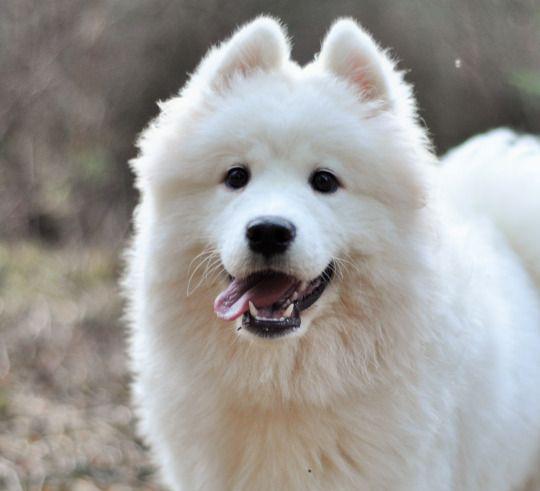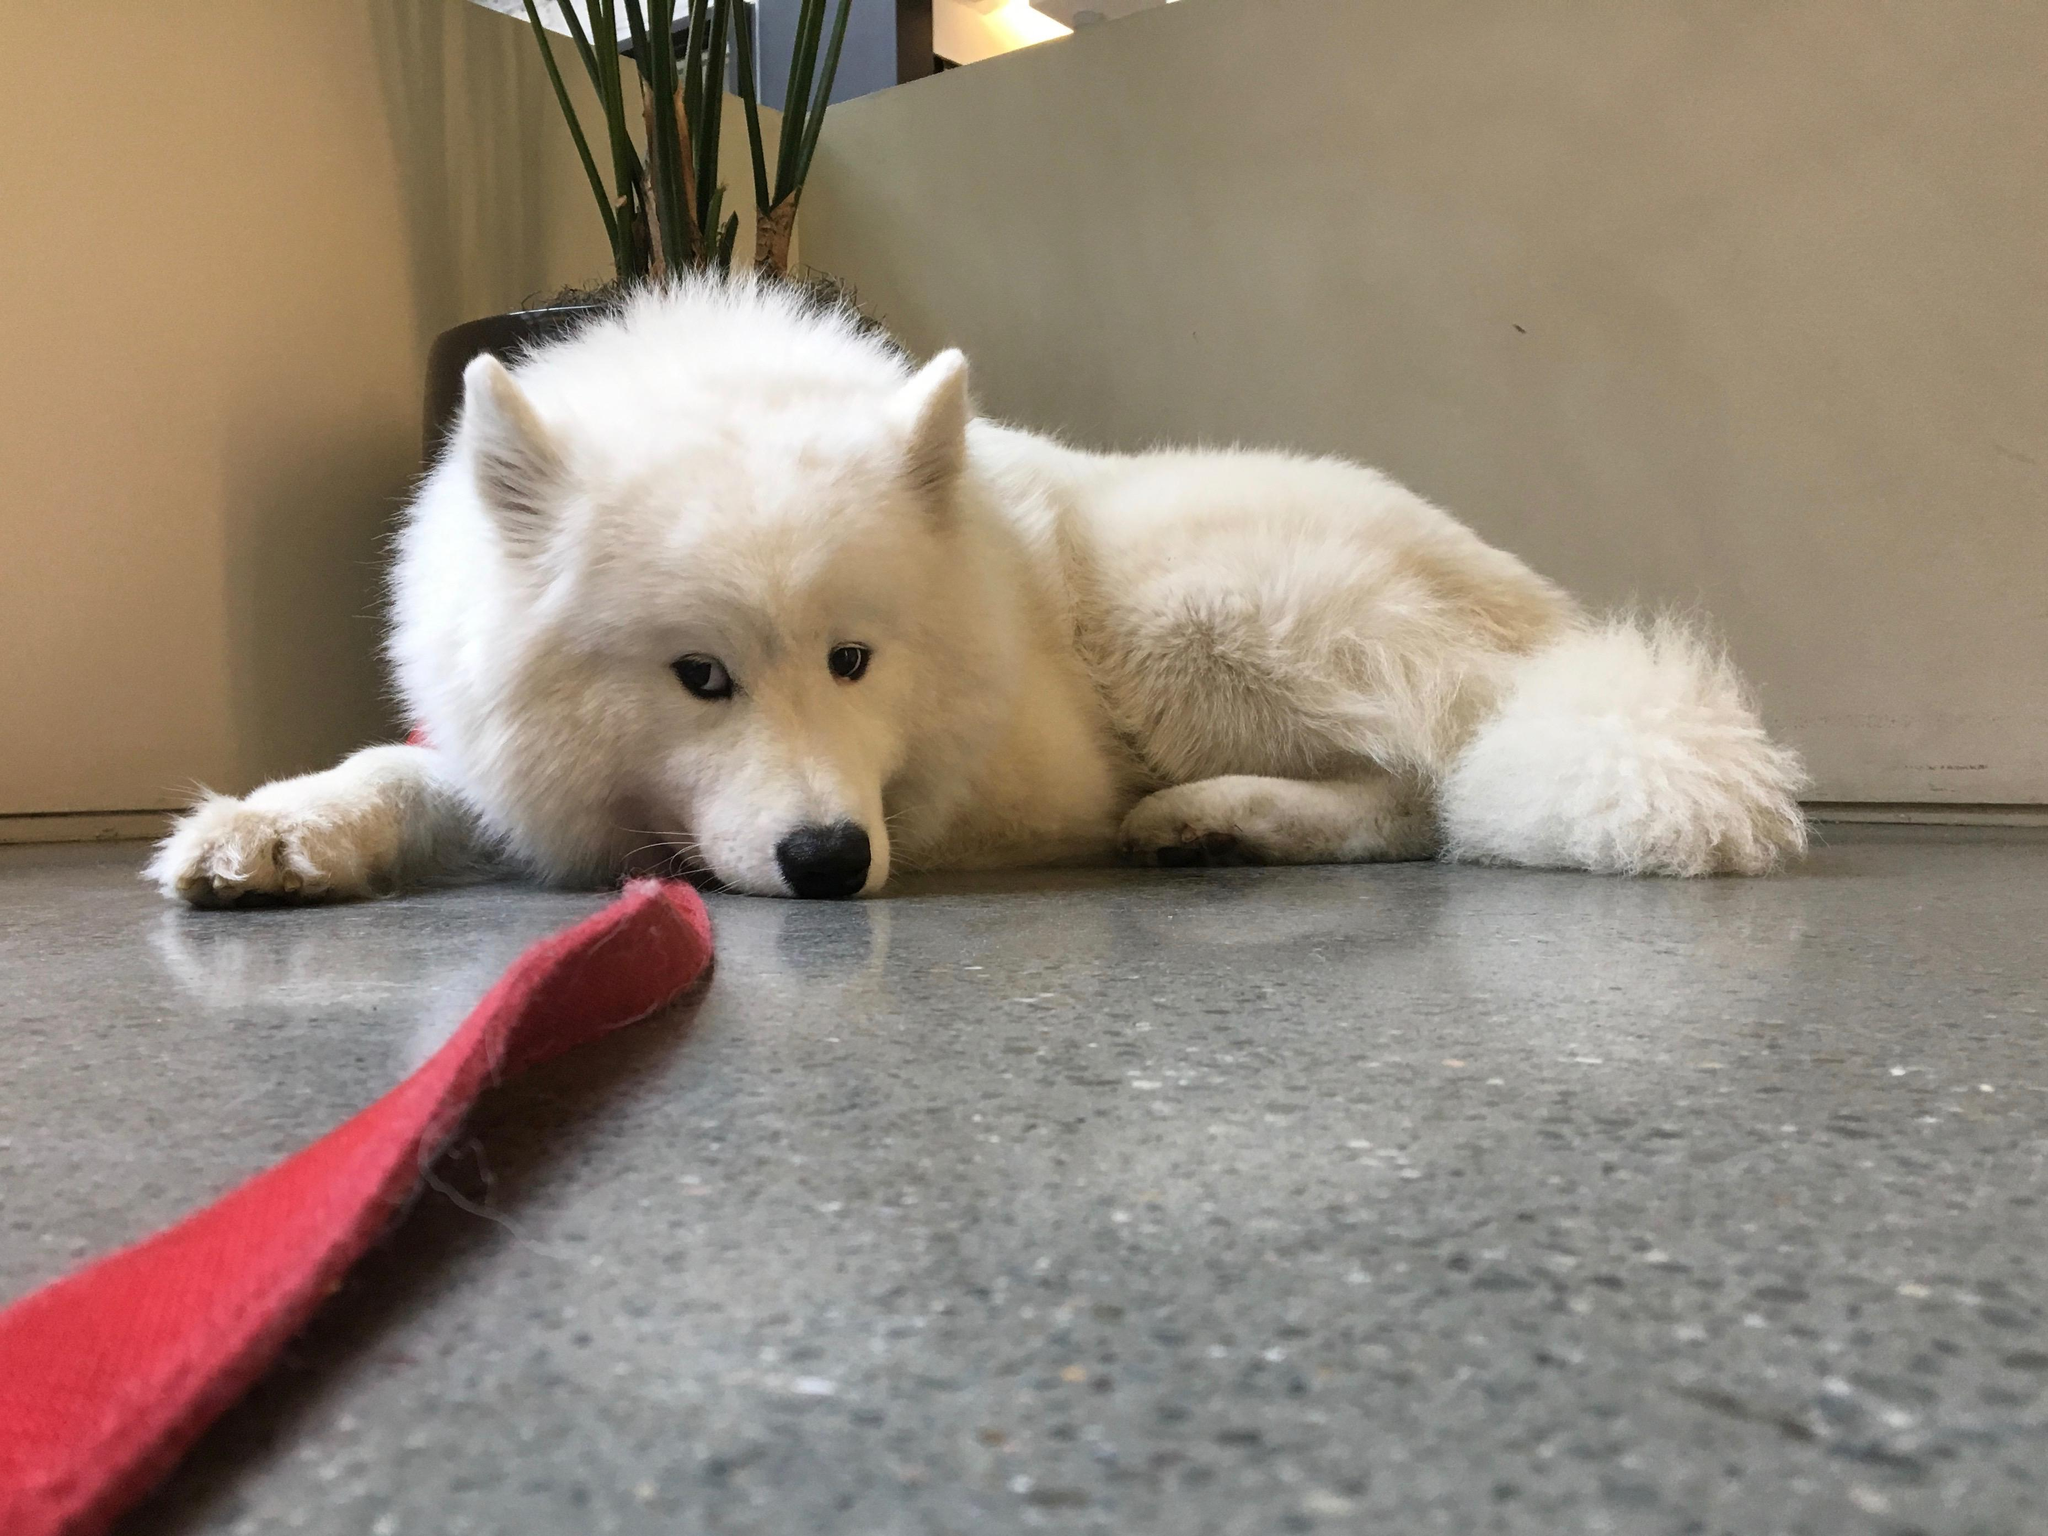The first image is the image on the left, the second image is the image on the right. Analyze the images presented: Is the assertion "One image features a rabbit next to a dog." valid? Answer yes or no. No. The first image is the image on the left, the second image is the image on the right. Considering the images on both sides, is "The left image contains a dog interacting with a rabbit." valid? Answer yes or no. No. 